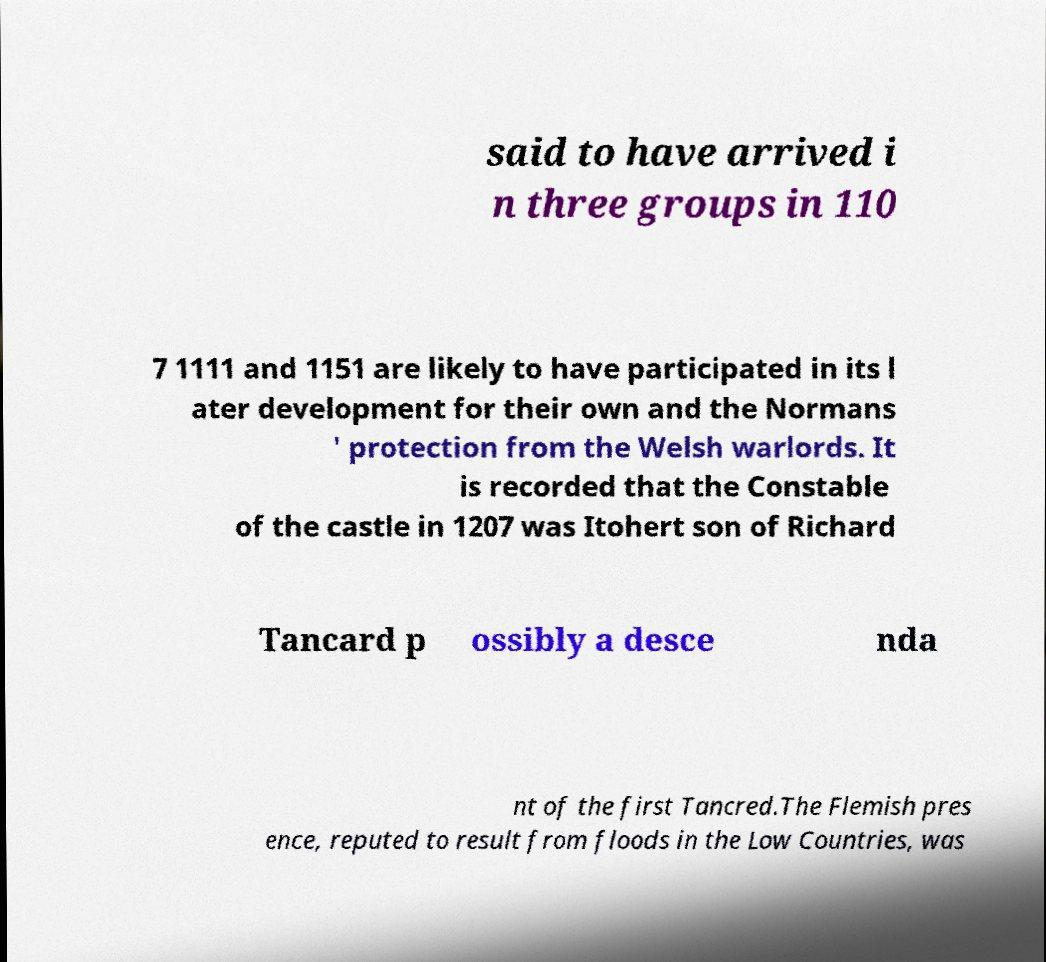For documentation purposes, I need the text within this image transcribed. Could you provide that? said to have arrived i n three groups in 110 7 1111 and 1151 are likely to have participated in its l ater development for their own and the Normans ' protection from the Welsh warlords. It is recorded that the Constable of the castle in 1207 was Itohert son of Richard Tancard p ossibly a desce nda nt of the first Tancred.The Flemish pres ence, reputed to result from floods in the Low Countries, was 